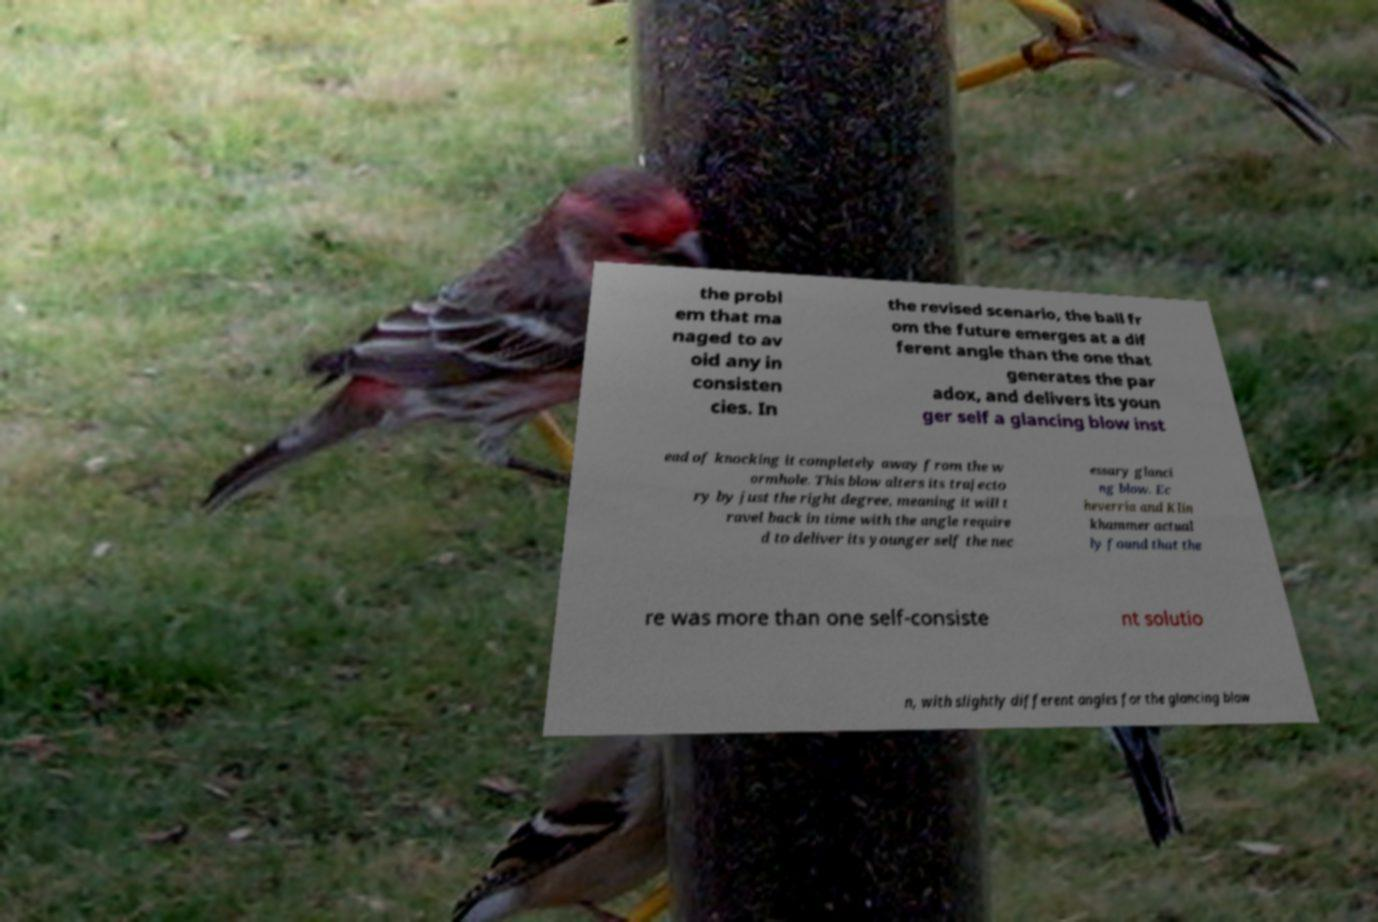I need the written content from this picture converted into text. Can you do that? the probl em that ma naged to av oid any in consisten cies. In the revised scenario, the ball fr om the future emerges at a dif ferent angle than the one that generates the par adox, and delivers its youn ger self a glancing blow inst ead of knocking it completely away from the w ormhole. This blow alters its trajecto ry by just the right degree, meaning it will t ravel back in time with the angle require d to deliver its younger self the nec essary glanci ng blow. Ec heverria and Klin khammer actual ly found that the re was more than one self-consiste nt solutio n, with slightly different angles for the glancing blow 